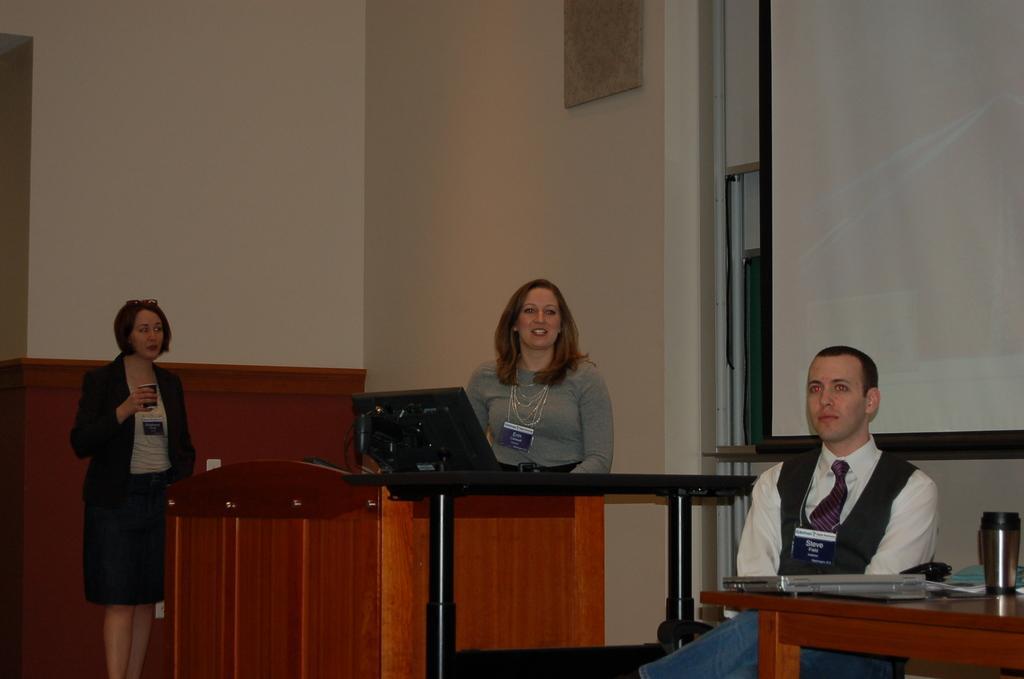How would you summarize this image in a sentence or two? In this image i can see a man sitting and 2 women standing, i can see a table on which there is a laptop and few other objects. In the background i can see a wall,a photo frame ,a monitor and a screen. 